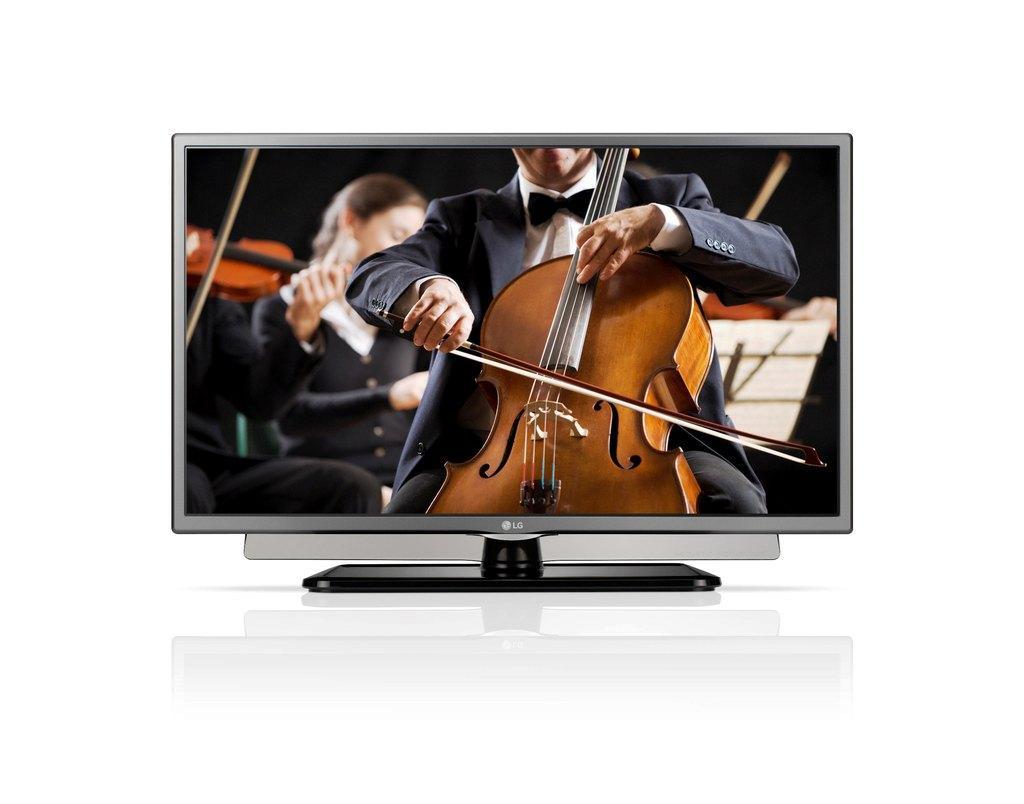Can you describe this image briefly? Here we can see a television, and a person is siting and playing the violin, and at back the persons are sitting. 